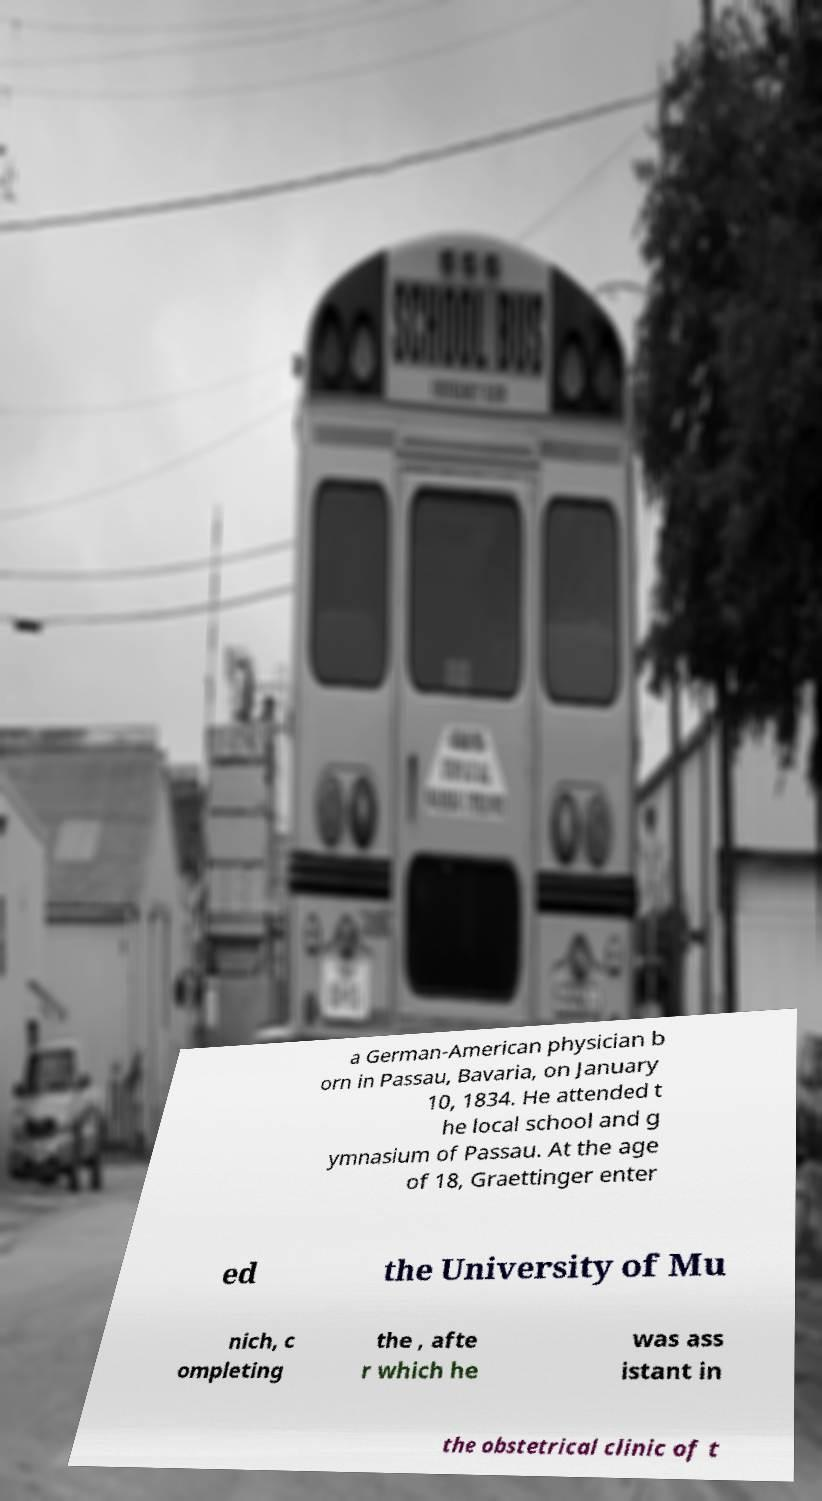Please read and relay the text visible in this image. What does it say? a German-American physician b orn in Passau, Bavaria, on January 10, 1834. He attended t he local school and g ymnasium of Passau. At the age of 18, Graettinger enter ed the University of Mu nich, c ompleting the , afte r which he was ass istant in the obstetrical clinic of t 